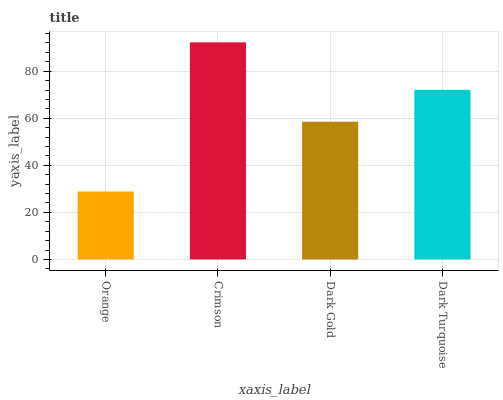Is Orange the minimum?
Answer yes or no. Yes. Is Crimson the maximum?
Answer yes or no. Yes. Is Dark Gold the minimum?
Answer yes or no. No. Is Dark Gold the maximum?
Answer yes or no. No. Is Crimson greater than Dark Gold?
Answer yes or no. Yes. Is Dark Gold less than Crimson?
Answer yes or no. Yes. Is Dark Gold greater than Crimson?
Answer yes or no. No. Is Crimson less than Dark Gold?
Answer yes or no. No. Is Dark Turquoise the high median?
Answer yes or no. Yes. Is Dark Gold the low median?
Answer yes or no. Yes. Is Dark Gold the high median?
Answer yes or no. No. Is Crimson the low median?
Answer yes or no. No. 